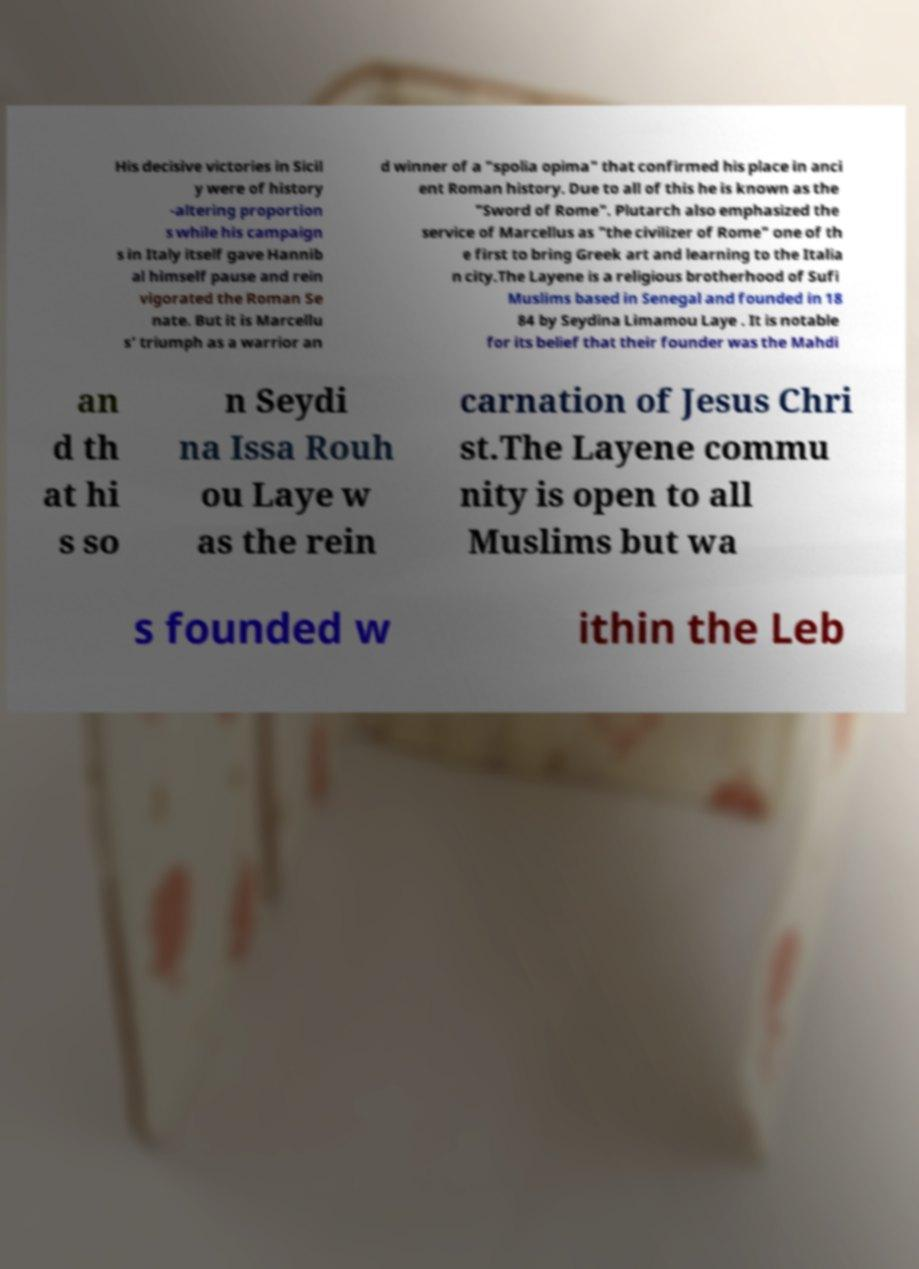What messages or text are displayed in this image? I need them in a readable, typed format. His decisive victories in Sicil y were of history -altering proportion s while his campaign s in Italy itself gave Hannib al himself pause and rein vigorated the Roman Se nate. But it is Marcellu s’ triumph as a warrior an d winner of a "spolia opima" that confirmed his place in anci ent Roman history. Due to all of this he is known as the "Sword of Rome". Plutarch also emphasized the service of Marcellus as "the civilizer of Rome" one of th e first to bring Greek art and learning to the Italia n city.The Layene is a religious brotherhood of Sufi Muslims based in Senegal and founded in 18 84 by Seydina Limamou Laye . It is notable for its belief that their founder was the Mahdi an d th at hi s so n Seydi na Issa Rouh ou Laye w as the rein carnation of Jesus Chri st.The Layene commu nity is open to all Muslims but wa s founded w ithin the Leb 